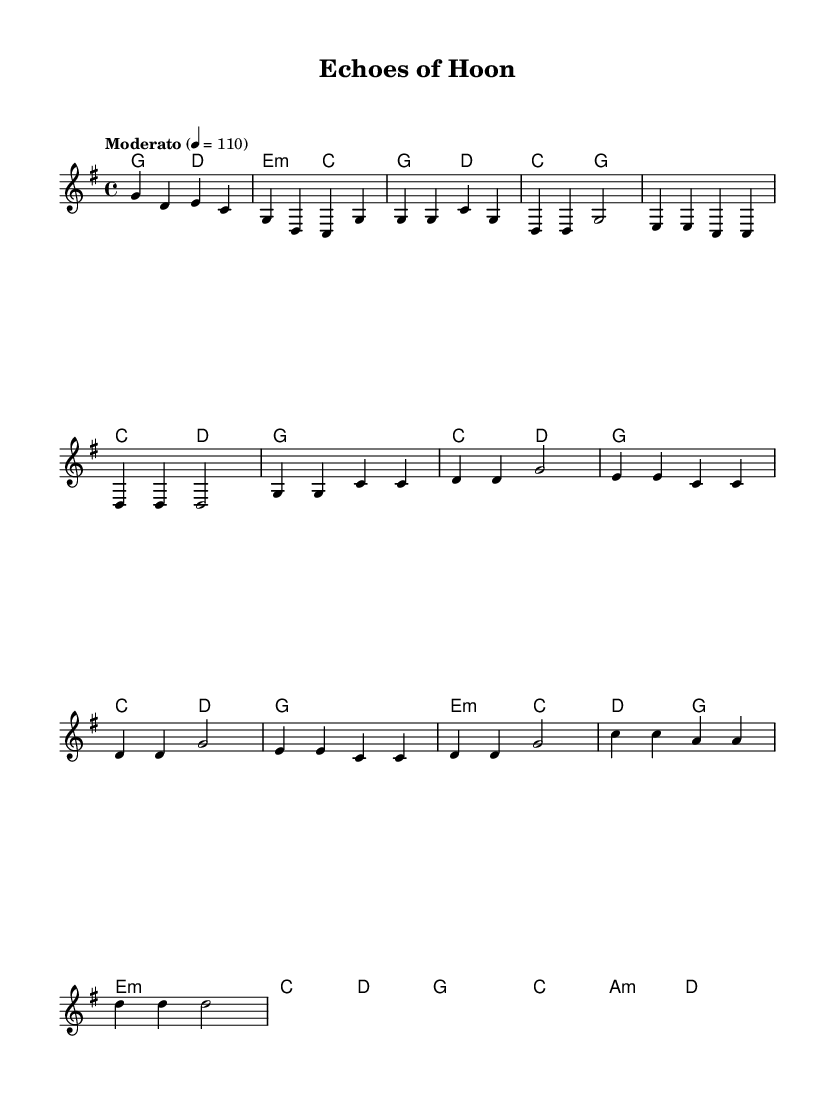What is the key signature of this music? The key signature in the sheet music is G major, which has one sharp (F#). This can be identified by looking at the beginning of the staff where the key signature is located.
Answer: G major What is the time signature of this music? The time signature is found in the initial measures, indicated by the numbers at the beginning. It shows that there are 4 beats in each measure and a quarter note receives one beat.
Answer: 4/4 What is the tempo marking of this piece? The tempo marking is located at the beginning of the score which indicates how fast the music should be played. Here it specifies "Moderato" with a metronome marking.
Answer: Moderato 4 = 110 How many measures are there in the chorus section? The chorus section, as indicated by the structure of the music, consists of 4 measures. This can be counted directly from the musical notation shown in the chorus part of the score.
Answer: 4 What chord follows the E minor chord in the progression? By looking at the harmonies section, immediately after the E minor chord (E:m), the next chord shown is C major (c). This indicates the chord progression direction.
Answer: C Which section includes a bridge? The bridge is clearly labeled in the structure of the piece and is found after the verse and before the last chorus. It is distinct in its layout and placement in the music.
Answer: Bridge 